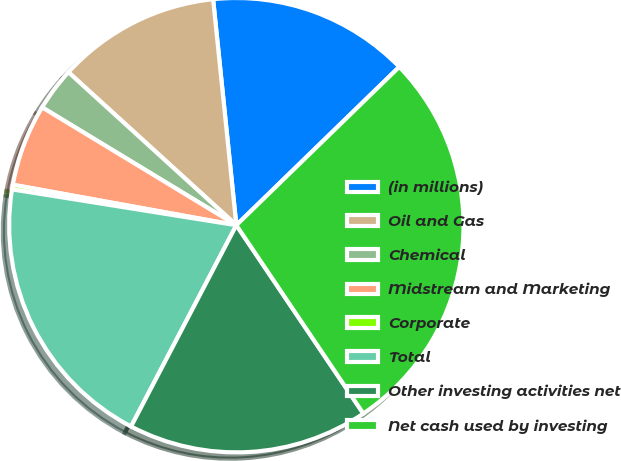<chart> <loc_0><loc_0><loc_500><loc_500><pie_chart><fcel>(in millions)<fcel>Oil and Gas<fcel>Chemical<fcel>Midstream and Marketing<fcel>Corporate<fcel>Total<fcel>Other investing activities net<fcel>Net cash used by investing<nl><fcel>14.36%<fcel>11.61%<fcel>3.08%<fcel>5.83%<fcel>0.33%<fcel>19.85%<fcel>17.11%<fcel>27.83%<nl></chart> 